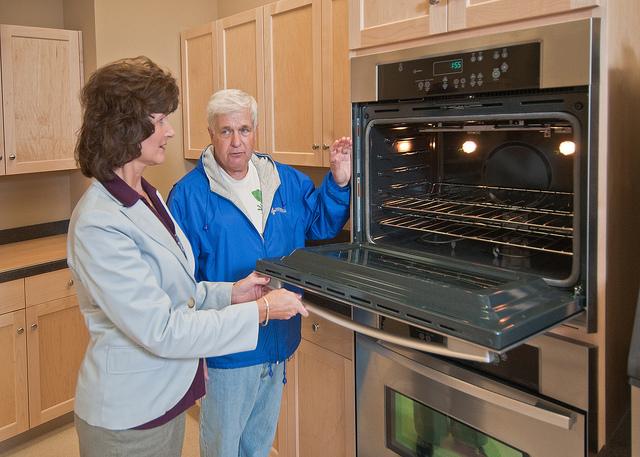Does the stove need cleaned?
Quick response, please. No. Does he have gray hair?
Write a very short answer. Yes. Is the oven on?
Keep it brief. No. 